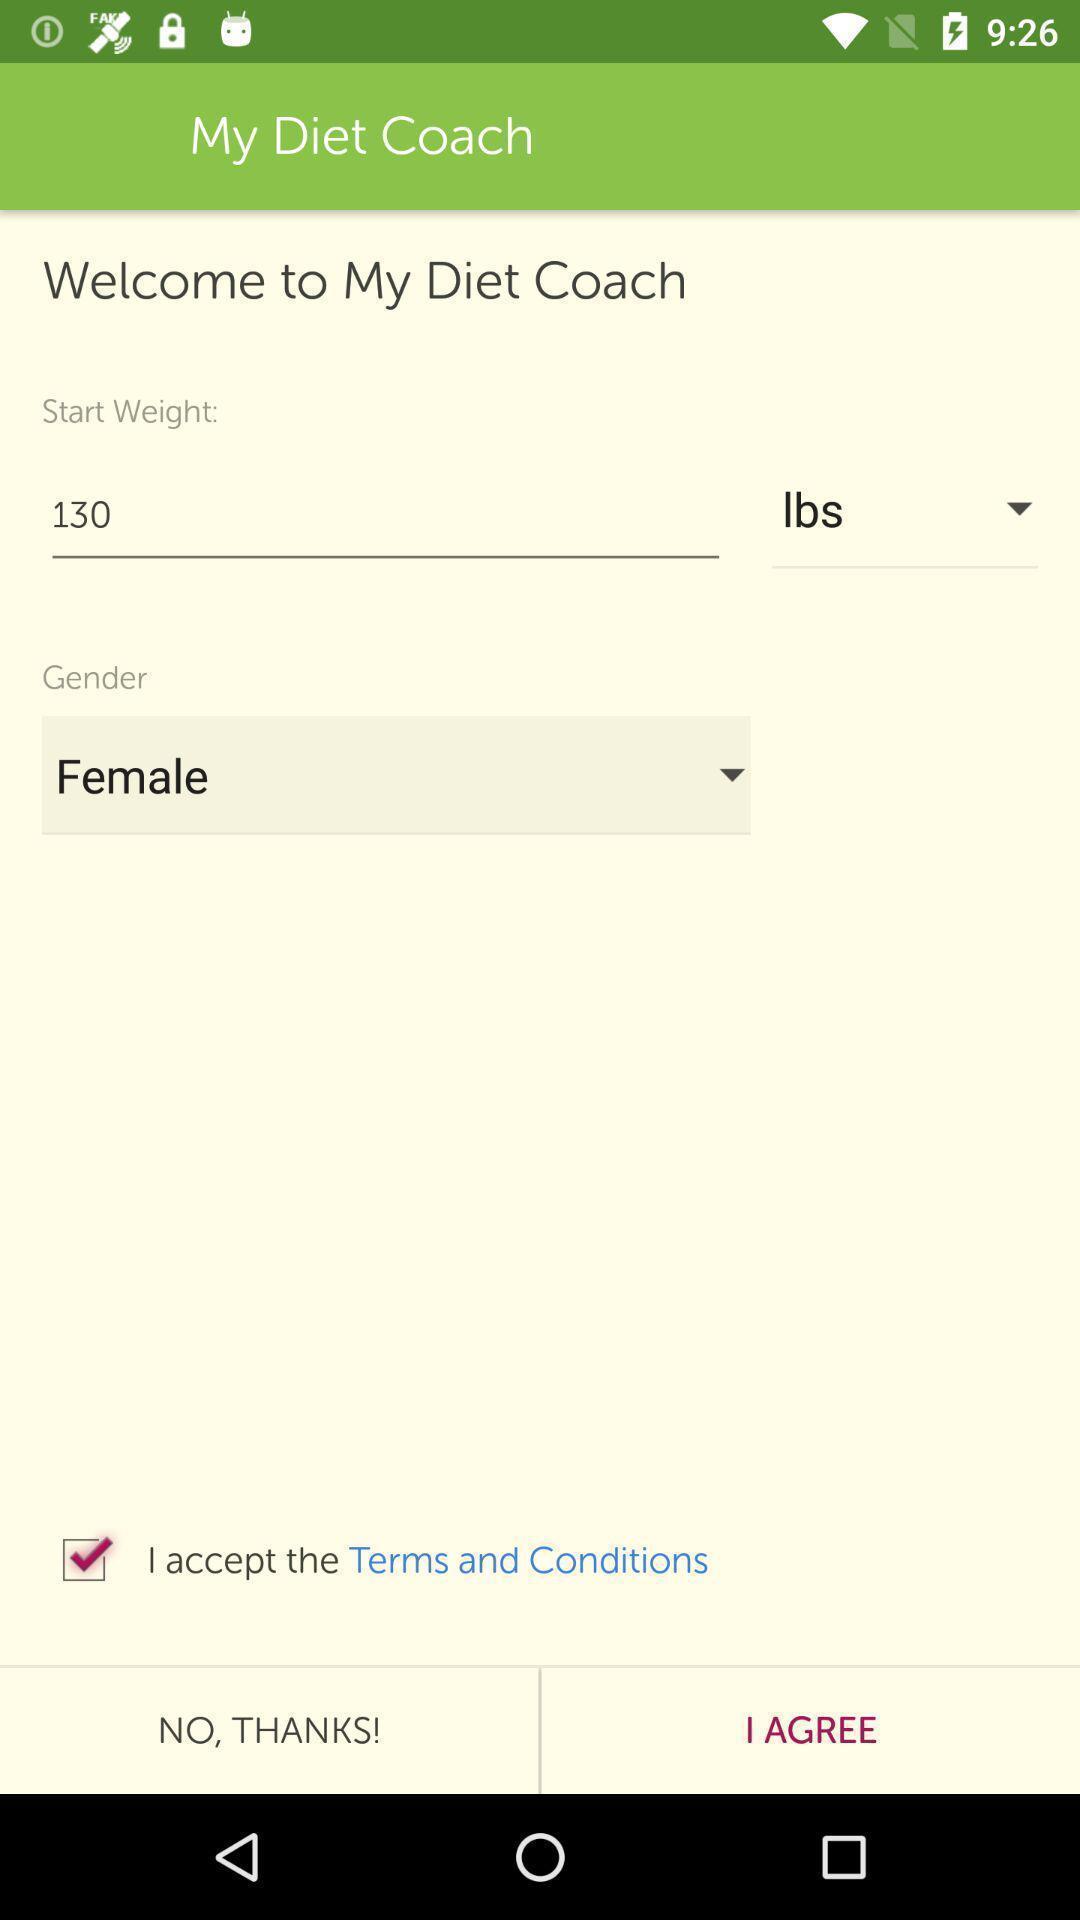Please provide a description for this image. User details for diet app. 